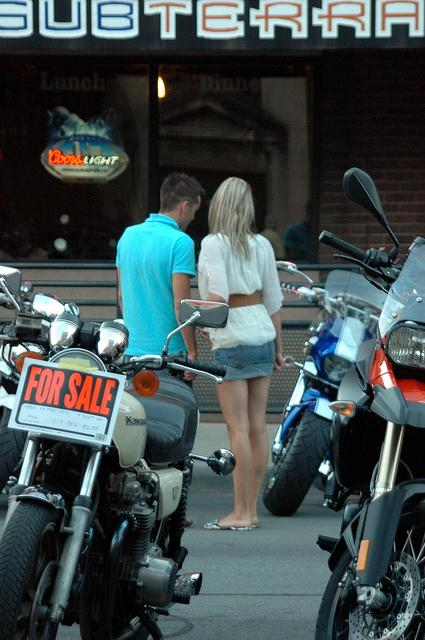What kind of shop is shown in the background? bar 